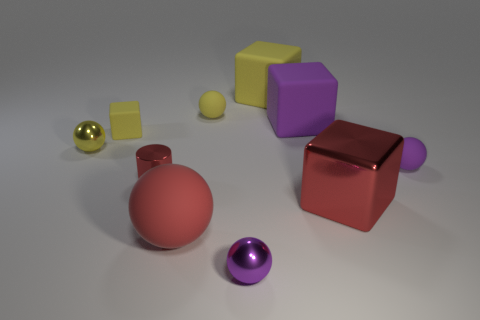There is a tiny thing that is the same color as the large shiny block; what is its material?
Your response must be concise. Metal. Are there any other things that are the same shape as the small red metallic object?
Offer a very short reply. No. There is a large yellow block; are there any small spheres right of it?
Give a very brief answer. Yes. There is a tiny object that is on the right side of the tiny purple metallic thing; is it the same color as the large rubber cube that is in front of the yellow rubber ball?
Offer a terse response. Yes. Is there a yellow rubber thing of the same shape as the large purple rubber object?
Your answer should be very brief. Yes. What number of other objects are there of the same color as the large ball?
Your answer should be very brief. 2. The tiny matte ball that is in front of the block that is on the left side of the tiny shiny ball that is in front of the tiny purple rubber ball is what color?
Make the answer very short. Purple. Is the number of big purple matte blocks that are in front of the red metallic cylinder the same as the number of small purple objects?
Keep it short and to the point. No. There is a red metal object that is on the right side of the yellow rubber sphere; does it have the same size as the cylinder?
Provide a succinct answer. No. How many gray metallic cubes are there?
Offer a terse response. 0. 